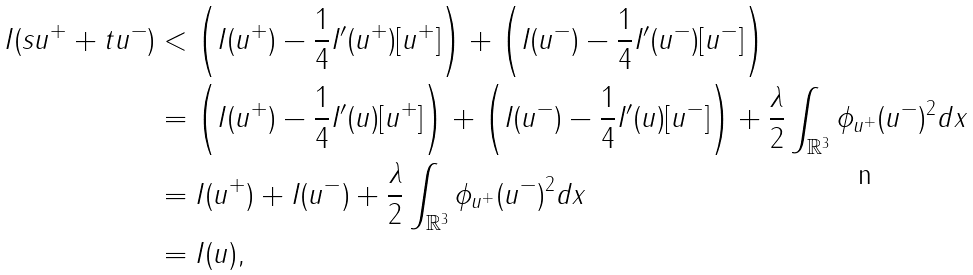Convert formula to latex. <formula><loc_0><loc_0><loc_500><loc_500>I ( s u ^ { + } + t u ^ { - } ) & < \left ( I ( u ^ { + } ) - \frac { 1 } { 4 } I ^ { \prime } ( u ^ { + } ) [ u ^ { + } ] \right ) + \left ( I ( u ^ { - } ) - \frac { 1 } { 4 } I ^ { \prime } ( u ^ { - } ) [ u ^ { - } ] \right ) \\ & = \left ( I ( u ^ { + } ) - \frac { 1 } { 4 } I ^ { \prime } ( u ) [ u ^ { + } ] \right ) + \left ( I ( u ^ { - } ) - \frac { 1 } { 4 } I ^ { \prime } ( u ) [ u ^ { - } ] \right ) + \frac { \lambda } { 2 } \int _ { \mathbb { R } ^ { 3 } } \phi _ { u ^ { + } } ( u ^ { - } ) ^ { 2 } d x \\ & = I ( u ^ { + } ) + I ( u ^ { - } ) + \frac { \lambda } { 2 } \int _ { \mathbb { R } ^ { 3 } } \phi _ { u ^ { + } } ( u ^ { - } ) ^ { 2 } d x \\ & = I ( u ) ,</formula> 